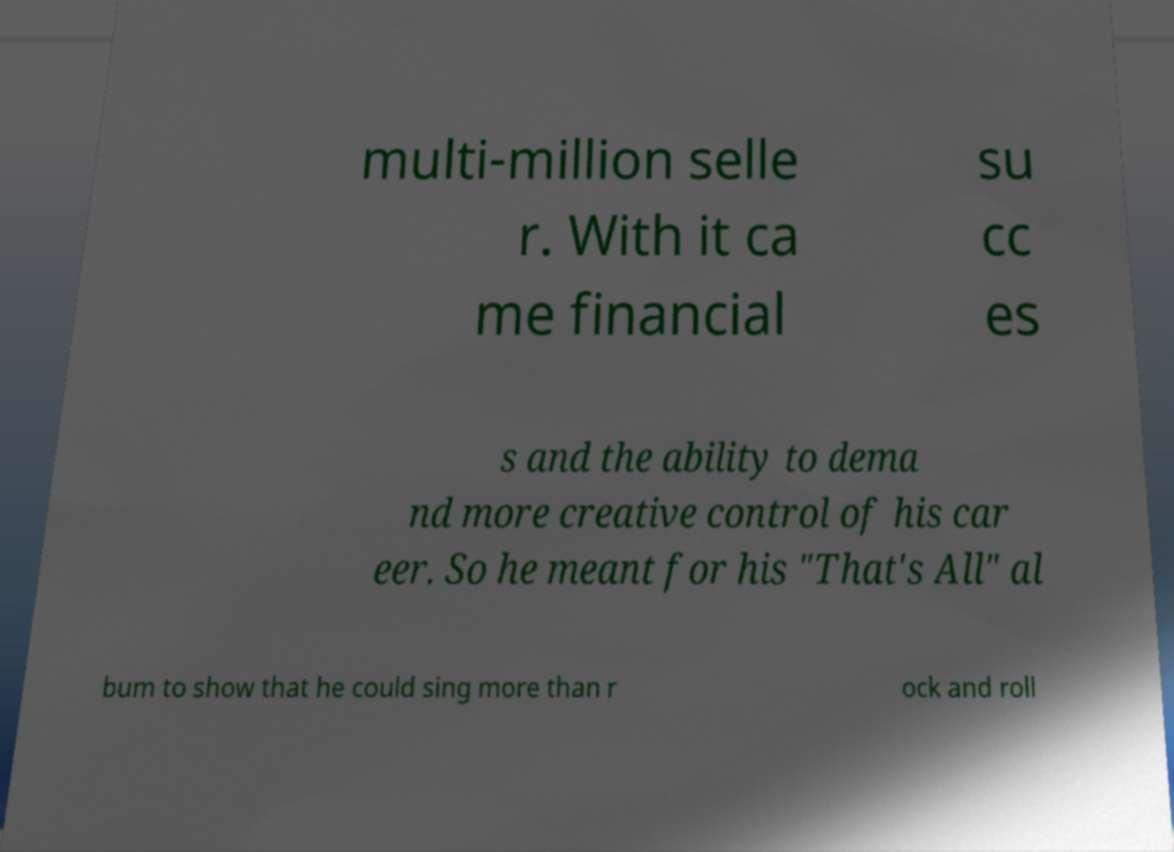Can you read and provide the text displayed in the image?This photo seems to have some interesting text. Can you extract and type it out for me? multi-million selle r. With it ca me financial su cc es s and the ability to dema nd more creative control of his car eer. So he meant for his "That's All" al bum to show that he could sing more than r ock and roll 